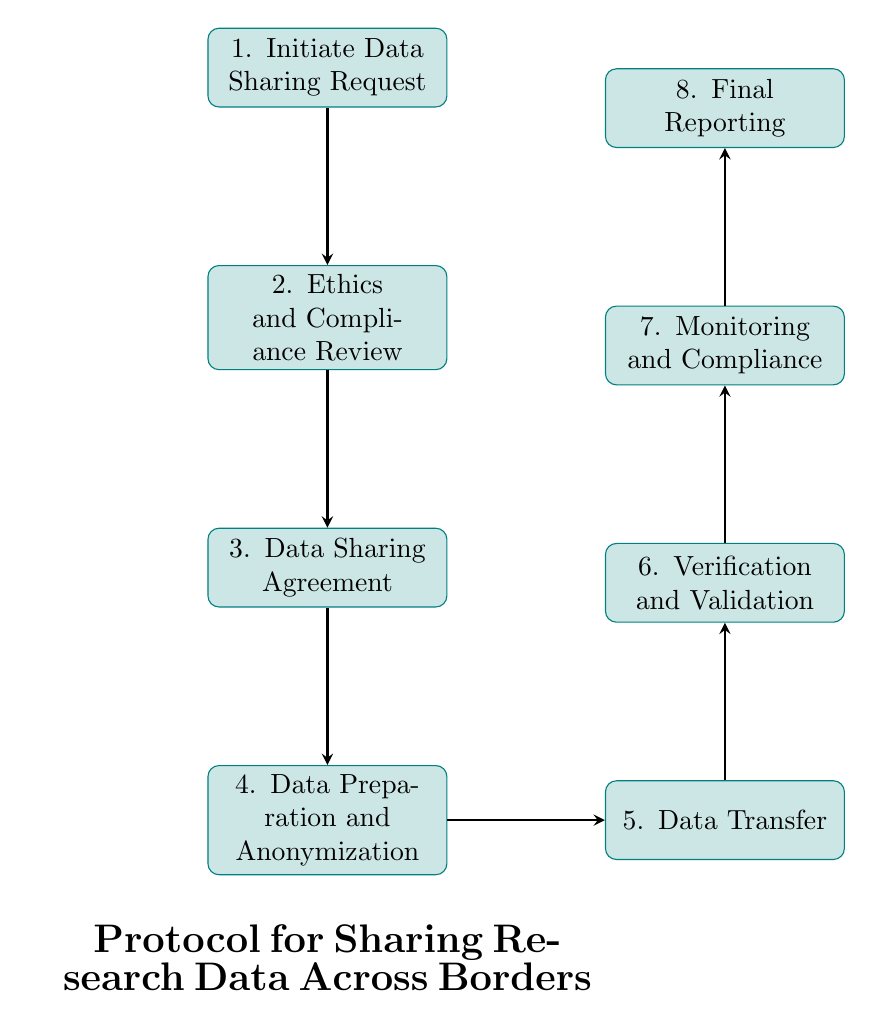What is the first step in the data sharing protocol? The first node in the flow chart is "Initiate Data Sharing Request," indicating that the process begins with this action.
Answer: Initiate Data Sharing Request How many total steps are there in the protocol? By counting the nodes in the diagram, we see there are eight steps, from initiating the request to final reporting.
Answer: Eight What is the final step of the protocol? The last node in the flow chart is "Final Reporting," which signifies the conclusion of the data-sharing process.
Answer: Final Reporting Which step involves legal documentation? The node "Data Sharing Agreement" specifically indicates the drafting and finalization of a legal agreement related to data sharing.
Answer: Data Sharing Agreement What step comes directly after “Data Preparation and Anonymization”? Following the node "Data Preparation and Anonymization," the next step in the flow chart is "Data Transfer."
Answer: Data Transfer Which steps are focused on compliance? The steps that emphasize compliance are "Ethics and Compliance Review," "Monitoring and Compliance," and "Final Reporting," as they all involve aspects of adherence to ethical and legal standards.
Answer: Ethics and Compliance Review, Monitoring and Compliance, Final Reporting What action is performed after data transfer? After the "Data Transfer" step, the "Verification and Validation" step is performed to ensure the integrity and completeness of the data received.
Answer: Verification and Validation What key activity is highlighted in the "Data Preparation and Anonymization" step? This step emphasizes the importance of preparing and anonymizing the data to protect personal and sensitive information before sharing.
Answer: Preparing and anonymizing the data 